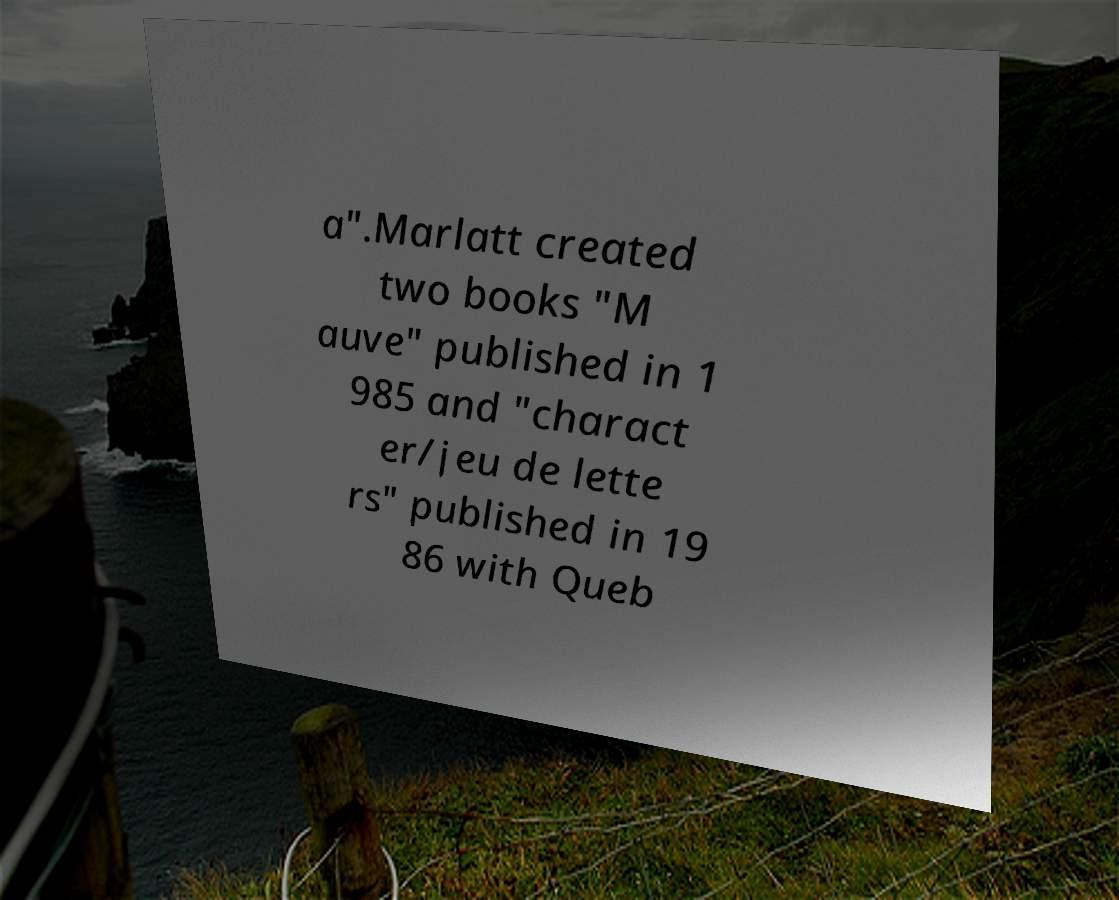Please identify and transcribe the text found in this image. a".Marlatt created two books "M auve" published in 1 985 and "charact er/jeu de lette rs" published in 19 86 with Queb 